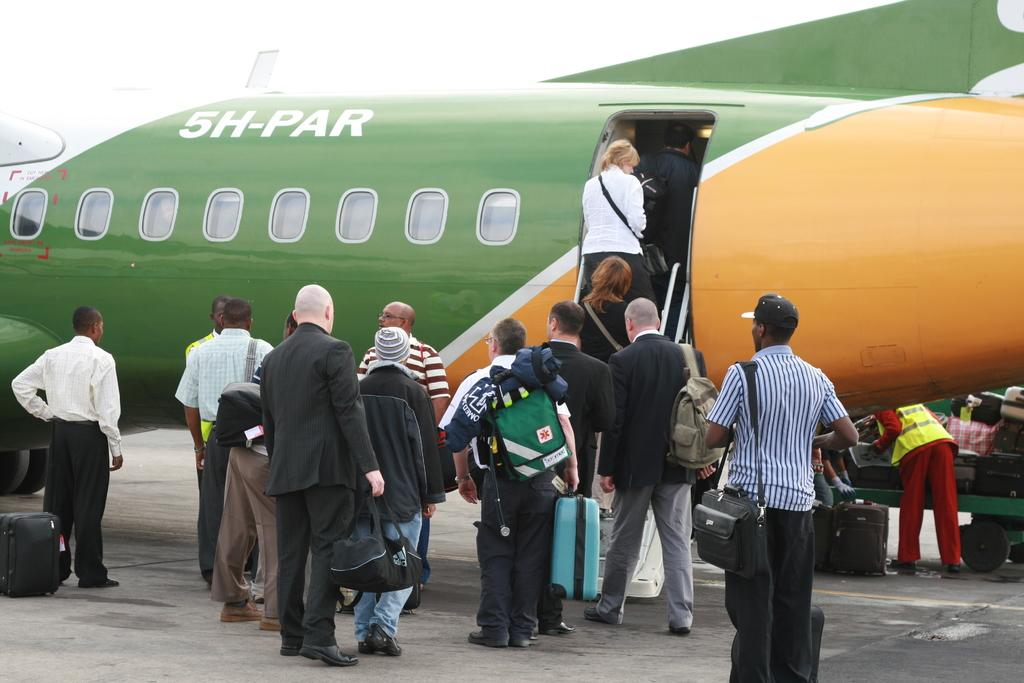<image>
Give a short and clear explanation of the subsequent image. people boarding a green and orange plane with 5H-PAR on the side 